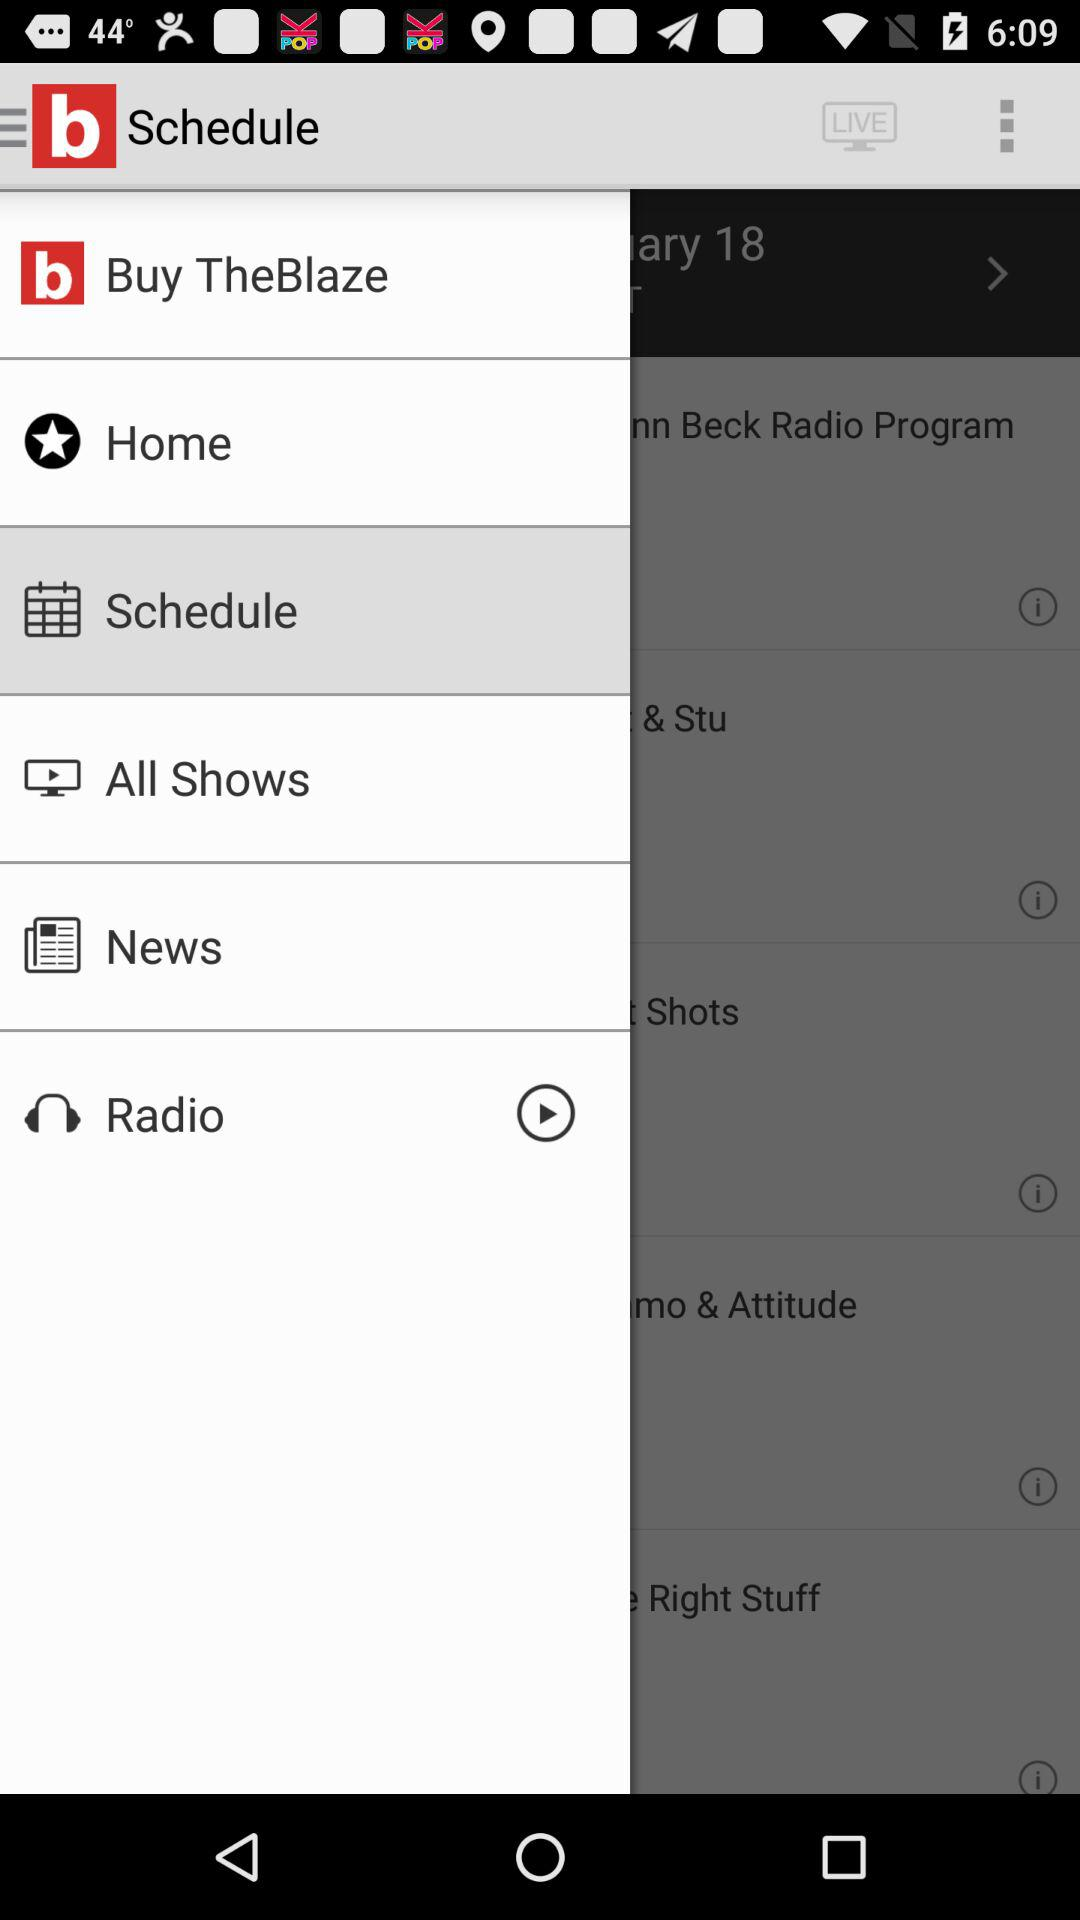Which item is selected in the menu? The selected item is "Schedule". 